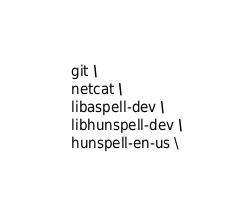<code> <loc_0><loc_0><loc_500><loc_500><_Dockerfile_>  git \
  netcat \
  libaspell-dev \
  libhunspell-dev \
  hunspell-en-us \</code> 